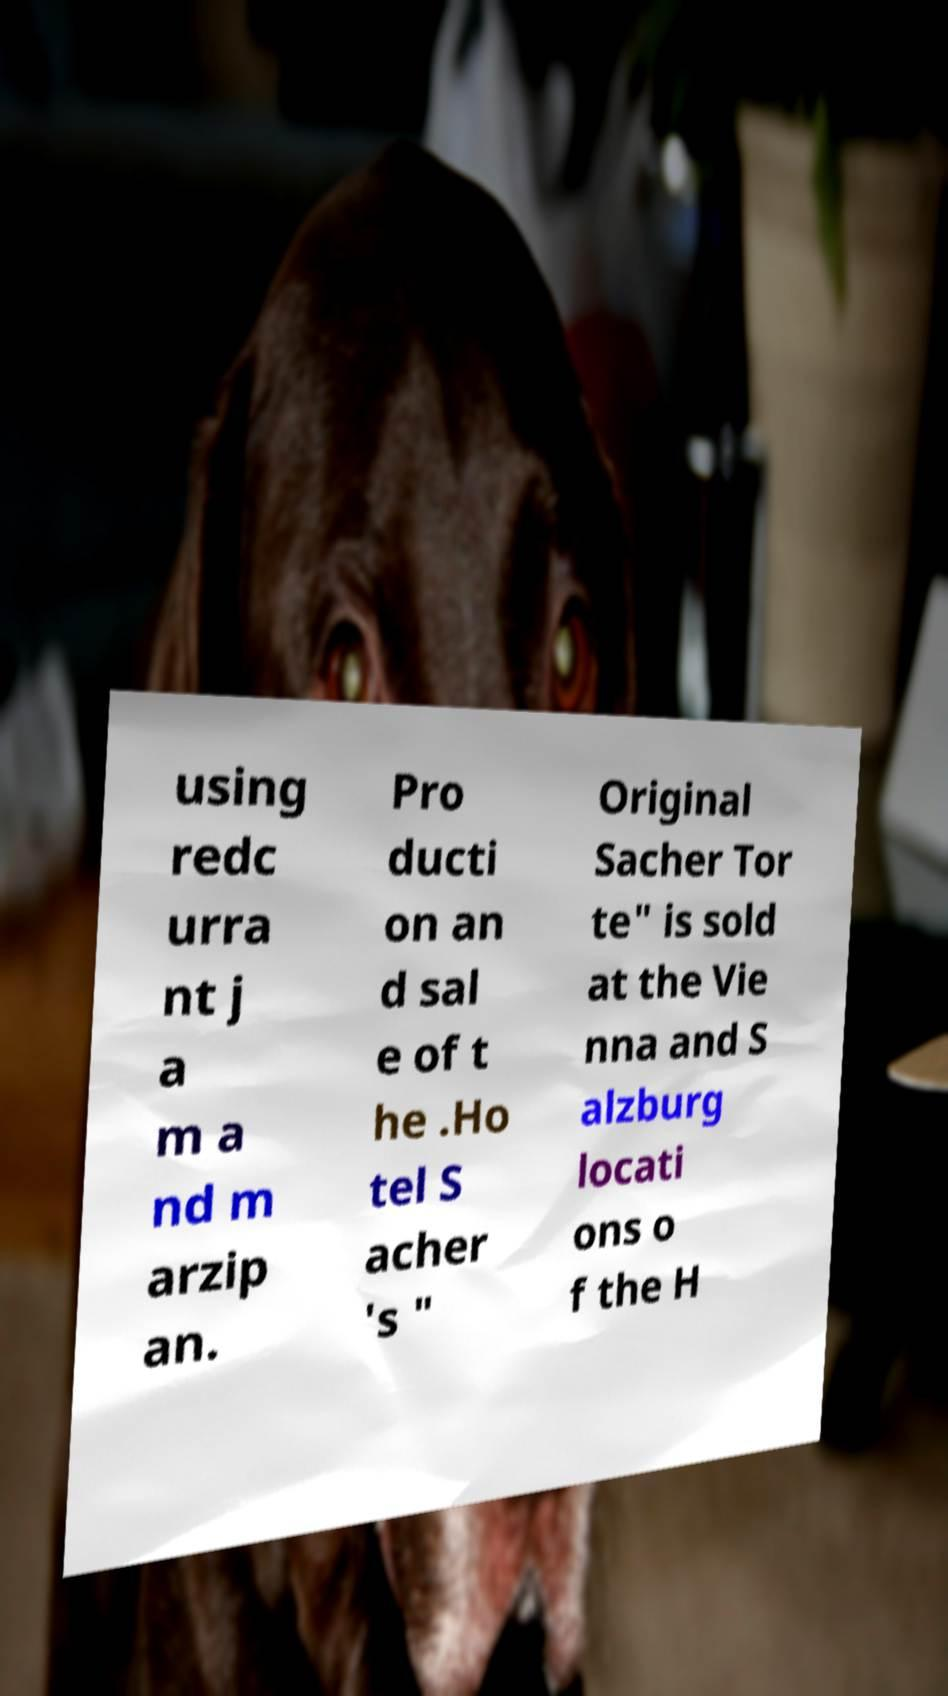What messages or text are displayed in this image? I need them in a readable, typed format. using redc urra nt j a m a nd m arzip an. Pro ducti on an d sal e of t he .Ho tel S acher 's " Original Sacher Tor te" is sold at the Vie nna and S alzburg locati ons o f the H 